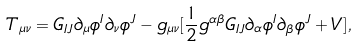<formula> <loc_0><loc_0><loc_500><loc_500>T _ { \mu \nu } = G _ { I J } \partial _ { \mu } \phi ^ { I } \partial _ { \nu } \phi ^ { J } - g _ { \mu \nu } [ \frac { 1 } { 2 } g ^ { \alpha \beta } G _ { I J } \partial _ { \alpha } \phi ^ { I } \partial _ { \beta } \phi ^ { J } + V ] ,</formula> 